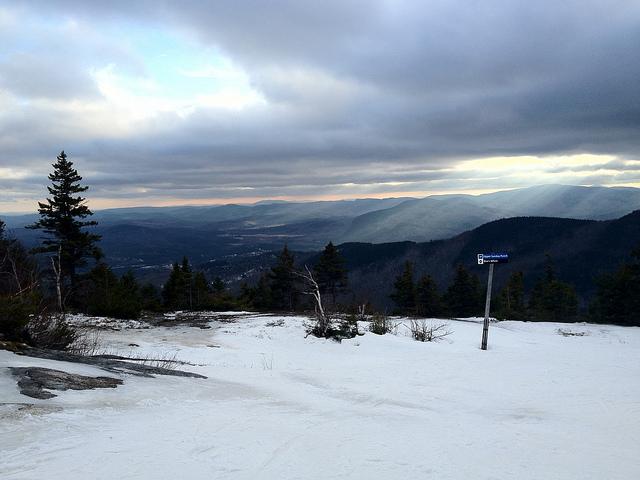Is this a steep hill?
Write a very short answer. Yes. Are the trees covered with snow?
Be succinct. No. Is it cloudy?
Concise answer only. Yes. Is there a break in the clouds?
Give a very brief answer. Yes. Are there houses on the hill?
Concise answer only. No. What is on top of the mountains?
Keep it brief. Snow. Is the sky clear?
Short answer required. No. Have other people been in the snow?
Keep it brief. No. 